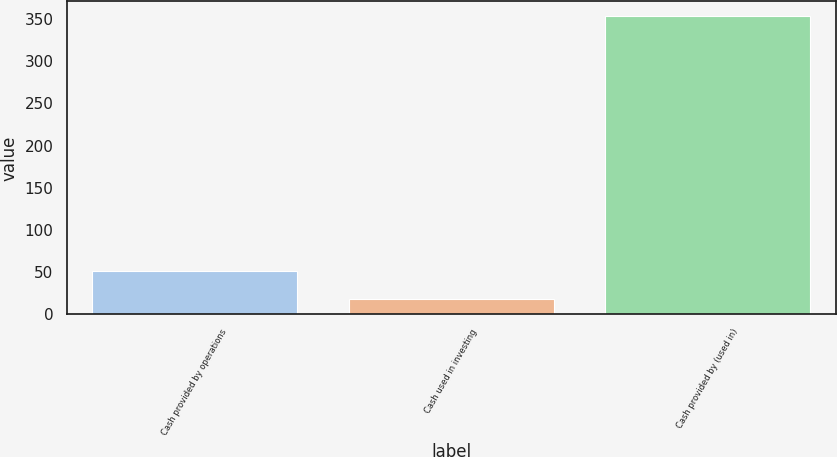Convert chart to OTSL. <chart><loc_0><loc_0><loc_500><loc_500><bar_chart><fcel>Cash provided by operations<fcel>Cash used in investing<fcel>Cash provided by (used in)<nl><fcel>51.5<fcel>18<fcel>353<nl></chart> 